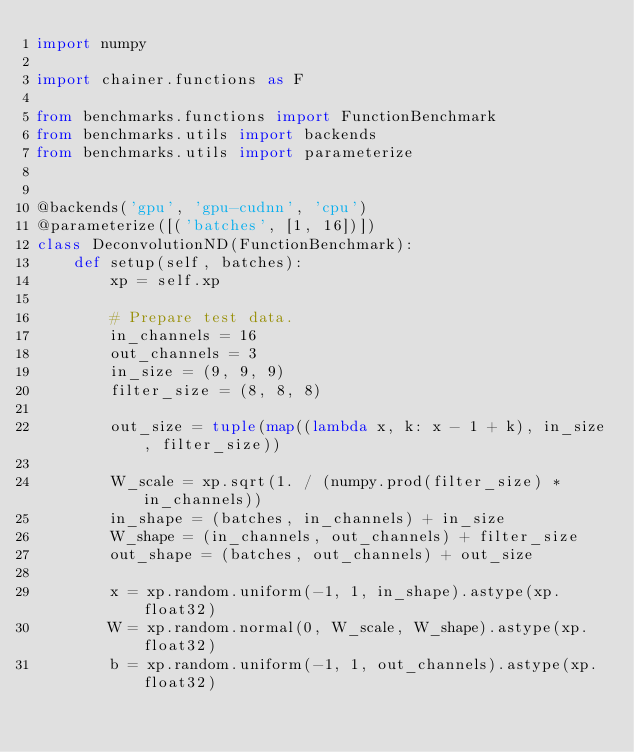<code> <loc_0><loc_0><loc_500><loc_500><_Python_>import numpy

import chainer.functions as F

from benchmarks.functions import FunctionBenchmark
from benchmarks.utils import backends
from benchmarks.utils import parameterize


@backends('gpu', 'gpu-cudnn', 'cpu')
@parameterize([('batches', [1, 16])])
class DeconvolutionND(FunctionBenchmark):
    def setup(self, batches):
        xp = self.xp

        # Prepare test data.
        in_channels = 16
        out_channels = 3
        in_size = (9, 9, 9)
        filter_size = (8, 8, 8)

        out_size = tuple(map((lambda x, k: x - 1 + k), in_size, filter_size))

        W_scale = xp.sqrt(1. / (numpy.prod(filter_size) * in_channels))
        in_shape = (batches, in_channels) + in_size
        W_shape = (in_channels, out_channels) + filter_size
        out_shape = (batches, out_channels) + out_size

        x = xp.random.uniform(-1, 1, in_shape).astype(xp.float32)
        W = xp.random.normal(0, W_scale, W_shape).astype(xp.float32)
        b = xp.random.uniform(-1, 1, out_channels).astype(xp.float32)</code> 